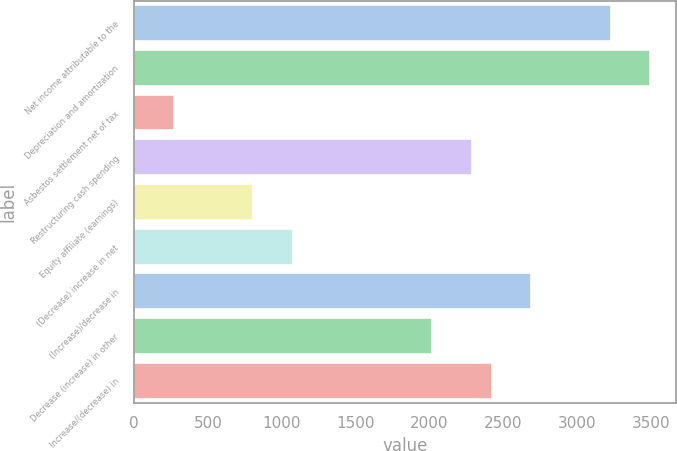<chart> <loc_0><loc_0><loc_500><loc_500><bar_chart><fcel>Net income attributable to the<fcel>Depreciation and amortization<fcel>Asbestos settlement net of tax<fcel>Restructuring cash spending<fcel>Equity affiliate (earnings)<fcel>(Decrease) increase in net<fcel>(Increase)/decrease in<fcel>Decrease (increase) in other<fcel>Increase/(decrease) in<nl><fcel>3226.6<fcel>3495.4<fcel>269.8<fcel>2285.8<fcel>807.4<fcel>1076.2<fcel>2689<fcel>2017<fcel>2420.2<nl></chart> 